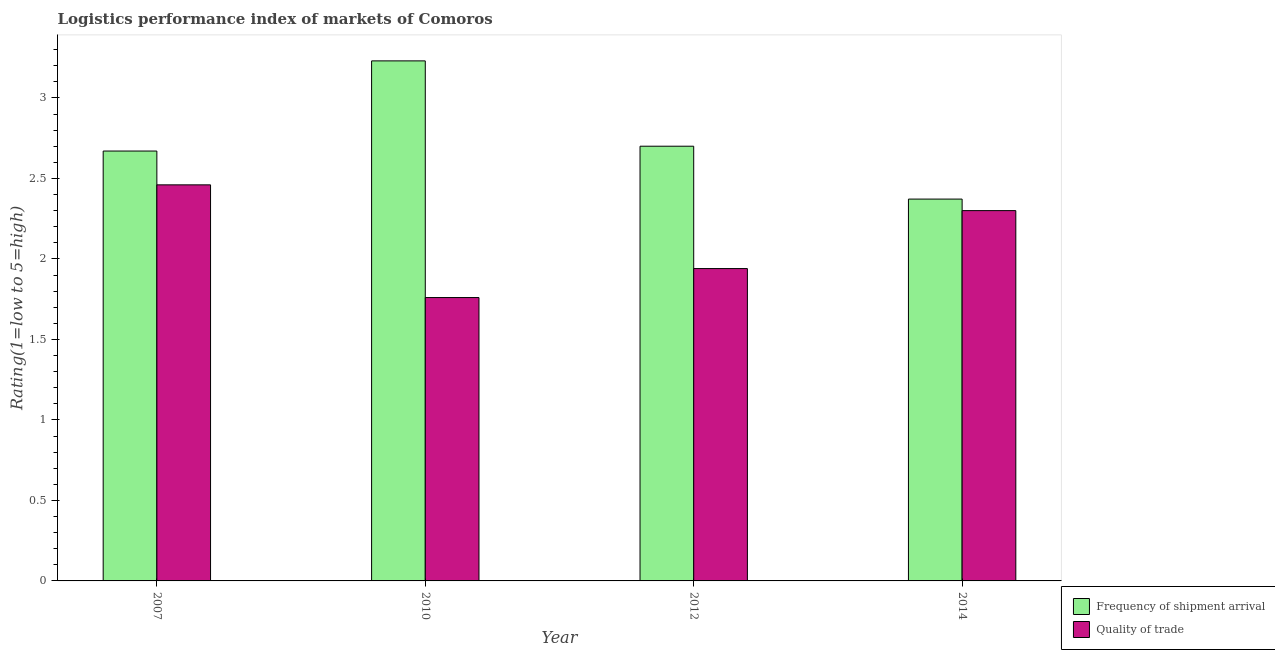How many different coloured bars are there?
Make the answer very short. 2. Are the number of bars per tick equal to the number of legend labels?
Keep it short and to the point. Yes. How many bars are there on the 4th tick from the left?
Offer a very short reply. 2. What is the label of the 4th group of bars from the left?
Your response must be concise. 2014. Across all years, what is the maximum lpi of frequency of shipment arrival?
Provide a succinct answer. 3.23. Across all years, what is the minimum lpi quality of trade?
Provide a short and direct response. 1.76. In which year was the lpi of frequency of shipment arrival maximum?
Keep it short and to the point. 2010. In which year was the lpi of frequency of shipment arrival minimum?
Offer a terse response. 2014. What is the total lpi quality of trade in the graph?
Keep it short and to the point. 8.46. What is the difference between the lpi of frequency of shipment arrival in 2010 and that in 2012?
Offer a terse response. 0.53. What is the difference between the lpi quality of trade in 2012 and the lpi of frequency of shipment arrival in 2014?
Provide a succinct answer. -0.36. What is the average lpi quality of trade per year?
Offer a very short reply. 2.12. In how many years, is the lpi of frequency of shipment arrival greater than 0.1?
Offer a terse response. 4. What is the ratio of the lpi of frequency of shipment arrival in 2007 to that in 2012?
Give a very brief answer. 0.99. Is the lpi quality of trade in 2007 less than that in 2014?
Provide a succinct answer. No. What is the difference between the highest and the second highest lpi of frequency of shipment arrival?
Make the answer very short. 0.53. What is the difference between the highest and the lowest lpi of frequency of shipment arrival?
Your answer should be compact. 0.86. What does the 1st bar from the left in 2014 represents?
Offer a very short reply. Frequency of shipment arrival. What does the 2nd bar from the right in 2014 represents?
Offer a terse response. Frequency of shipment arrival. How many bars are there?
Offer a very short reply. 8. Are all the bars in the graph horizontal?
Provide a succinct answer. No. What is the difference between two consecutive major ticks on the Y-axis?
Your response must be concise. 0.5. Does the graph contain any zero values?
Your answer should be very brief. No. How many legend labels are there?
Your answer should be compact. 2. How are the legend labels stacked?
Provide a succinct answer. Vertical. What is the title of the graph?
Offer a terse response. Logistics performance index of markets of Comoros. Does "Public funds" appear as one of the legend labels in the graph?
Your response must be concise. No. What is the label or title of the X-axis?
Offer a terse response. Year. What is the label or title of the Y-axis?
Keep it short and to the point. Rating(1=low to 5=high). What is the Rating(1=low to 5=high) of Frequency of shipment arrival in 2007?
Your answer should be very brief. 2.67. What is the Rating(1=low to 5=high) of Quality of trade in 2007?
Keep it short and to the point. 2.46. What is the Rating(1=low to 5=high) of Frequency of shipment arrival in 2010?
Your answer should be very brief. 3.23. What is the Rating(1=low to 5=high) of Quality of trade in 2010?
Offer a terse response. 1.76. What is the Rating(1=low to 5=high) in Quality of trade in 2012?
Your answer should be compact. 1.94. What is the Rating(1=low to 5=high) of Frequency of shipment arrival in 2014?
Give a very brief answer. 2.37. Across all years, what is the maximum Rating(1=low to 5=high) of Frequency of shipment arrival?
Provide a short and direct response. 3.23. Across all years, what is the maximum Rating(1=low to 5=high) in Quality of trade?
Keep it short and to the point. 2.46. Across all years, what is the minimum Rating(1=low to 5=high) of Frequency of shipment arrival?
Provide a succinct answer. 2.37. Across all years, what is the minimum Rating(1=low to 5=high) of Quality of trade?
Your answer should be very brief. 1.76. What is the total Rating(1=low to 5=high) of Frequency of shipment arrival in the graph?
Provide a succinct answer. 10.97. What is the total Rating(1=low to 5=high) in Quality of trade in the graph?
Provide a short and direct response. 8.46. What is the difference between the Rating(1=low to 5=high) in Frequency of shipment arrival in 2007 and that in 2010?
Keep it short and to the point. -0.56. What is the difference between the Rating(1=low to 5=high) of Quality of trade in 2007 and that in 2010?
Your answer should be very brief. 0.7. What is the difference between the Rating(1=low to 5=high) in Frequency of shipment arrival in 2007 and that in 2012?
Give a very brief answer. -0.03. What is the difference between the Rating(1=low to 5=high) in Quality of trade in 2007 and that in 2012?
Make the answer very short. 0.52. What is the difference between the Rating(1=low to 5=high) of Frequency of shipment arrival in 2007 and that in 2014?
Offer a very short reply. 0.3. What is the difference between the Rating(1=low to 5=high) of Quality of trade in 2007 and that in 2014?
Offer a terse response. 0.16. What is the difference between the Rating(1=low to 5=high) of Frequency of shipment arrival in 2010 and that in 2012?
Keep it short and to the point. 0.53. What is the difference between the Rating(1=low to 5=high) of Quality of trade in 2010 and that in 2012?
Your answer should be very brief. -0.18. What is the difference between the Rating(1=low to 5=high) in Frequency of shipment arrival in 2010 and that in 2014?
Offer a very short reply. 0.86. What is the difference between the Rating(1=low to 5=high) of Quality of trade in 2010 and that in 2014?
Provide a succinct answer. -0.54. What is the difference between the Rating(1=low to 5=high) of Frequency of shipment arrival in 2012 and that in 2014?
Give a very brief answer. 0.33. What is the difference between the Rating(1=low to 5=high) of Quality of trade in 2012 and that in 2014?
Keep it short and to the point. -0.36. What is the difference between the Rating(1=low to 5=high) in Frequency of shipment arrival in 2007 and the Rating(1=low to 5=high) in Quality of trade in 2010?
Give a very brief answer. 0.91. What is the difference between the Rating(1=low to 5=high) of Frequency of shipment arrival in 2007 and the Rating(1=low to 5=high) of Quality of trade in 2012?
Offer a very short reply. 0.73. What is the difference between the Rating(1=low to 5=high) in Frequency of shipment arrival in 2007 and the Rating(1=low to 5=high) in Quality of trade in 2014?
Ensure brevity in your answer.  0.37. What is the difference between the Rating(1=low to 5=high) of Frequency of shipment arrival in 2010 and the Rating(1=low to 5=high) of Quality of trade in 2012?
Provide a succinct answer. 1.29. What is the difference between the Rating(1=low to 5=high) in Frequency of shipment arrival in 2010 and the Rating(1=low to 5=high) in Quality of trade in 2014?
Provide a short and direct response. 0.93. What is the average Rating(1=low to 5=high) in Frequency of shipment arrival per year?
Your response must be concise. 2.74. What is the average Rating(1=low to 5=high) of Quality of trade per year?
Give a very brief answer. 2.12. In the year 2007, what is the difference between the Rating(1=low to 5=high) in Frequency of shipment arrival and Rating(1=low to 5=high) in Quality of trade?
Provide a succinct answer. 0.21. In the year 2010, what is the difference between the Rating(1=low to 5=high) of Frequency of shipment arrival and Rating(1=low to 5=high) of Quality of trade?
Your answer should be very brief. 1.47. In the year 2012, what is the difference between the Rating(1=low to 5=high) of Frequency of shipment arrival and Rating(1=low to 5=high) of Quality of trade?
Provide a succinct answer. 0.76. In the year 2014, what is the difference between the Rating(1=low to 5=high) of Frequency of shipment arrival and Rating(1=low to 5=high) of Quality of trade?
Ensure brevity in your answer.  0.07. What is the ratio of the Rating(1=low to 5=high) in Frequency of shipment arrival in 2007 to that in 2010?
Your response must be concise. 0.83. What is the ratio of the Rating(1=low to 5=high) in Quality of trade in 2007 to that in 2010?
Your answer should be compact. 1.4. What is the ratio of the Rating(1=low to 5=high) in Frequency of shipment arrival in 2007 to that in 2012?
Your answer should be very brief. 0.99. What is the ratio of the Rating(1=low to 5=high) of Quality of trade in 2007 to that in 2012?
Provide a succinct answer. 1.27. What is the ratio of the Rating(1=low to 5=high) of Frequency of shipment arrival in 2007 to that in 2014?
Make the answer very short. 1.13. What is the ratio of the Rating(1=low to 5=high) in Quality of trade in 2007 to that in 2014?
Offer a very short reply. 1.07. What is the ratio of the Rating(1=low to 5=high) in Frequency of shipment arrival in 2010 to that in 2012?
Ensure brevity in your answer.  1.2. What is the ratio of the Rating(1=low to 5=high) in Quality of trade in 2010 to that in 2012?
Your answer should be very brief. 0.91. What is the ratio of the Rating(1=low to 5=high) of Frequency of shipment arrival in 2010 to that in 2014?
Ensure brevity in your answer.  1.36. What is the ratio of the Rating(1=low to 5=high) in Quality of trade in 2010 to that in 2014?
Provide a succinct answer. 0.77. What is the ratio of the Rating(1=low to 5=high) of Frequency of shipment arrival in 2012 to that in 2014?
Make the answer very short. 1.14. What is the ratio of the Rating(1=low to 5=high) in Quality of trade in 2012 to that in 2014?
Provide a succinct answer. 0.84. What is the difference between the highest and the second highest Rating(1=low to 5=high) in Frequency of shipment arrival?
Provide a succinct answer. 0.53. What is the difference between the highest and the second highest Rating(1=low to 5=high) of Quality of trade?
Provide a short and direct response. 0.16. What is the difference between the highest and the lowest Rating(1=low to 5=high) in Frequency of shipment arrival?
Your answer should be compact. 0.86. What is the difference between the highest and the lowest Rating(1=low to 5=high) in Quality of trade?
Provide a short and direct response. 0.7. 